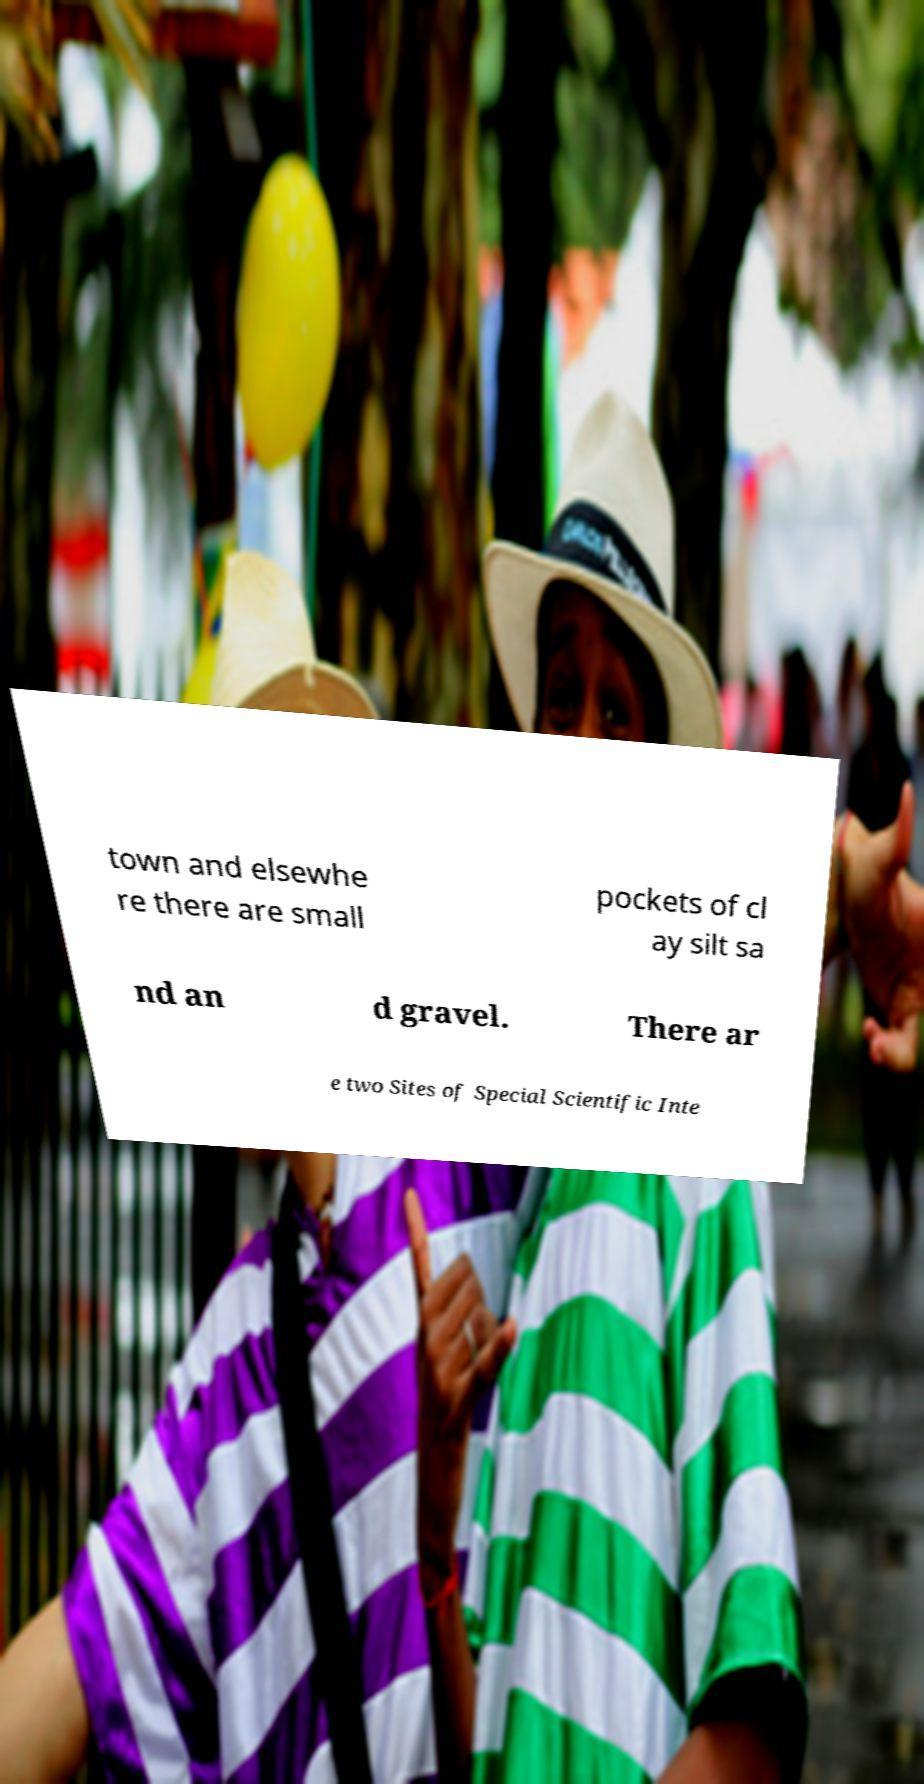There's text embedded in this image that I need extracted. Can you transcribe it verbatim? town and elsewhe re there are small pockets of cl ay silt sa nd an d gravel. There ar e two Sites of Special Scientific Inte 